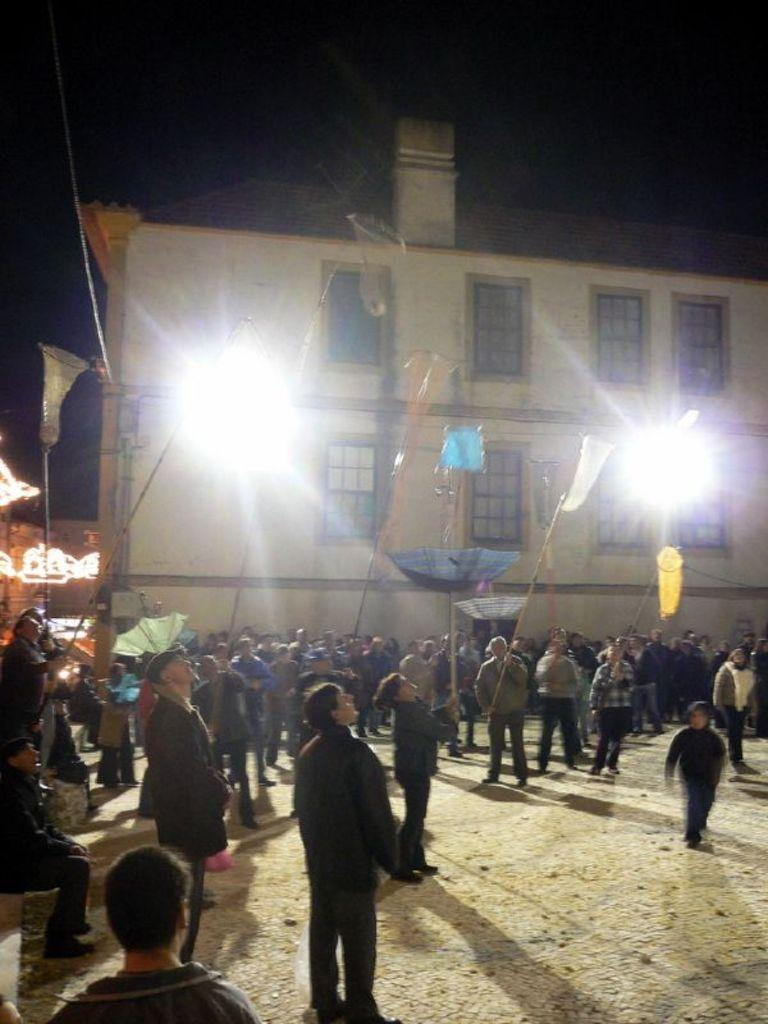What can be seen in the image? There is a group of people in the image. What are the people wearing? The people are wearing black shirts. What are the people doing in the image? The people are standing and holding sticks in their hands. What is visible in the background of the image? There is a white-colored building in the background. What are the characteristics of the building? The building has windows. How much debt does the building in the image have? There is no information about the building's debt in the image. What type of trip are the people in the image planning to take? There is no indication of a trip in the image. 